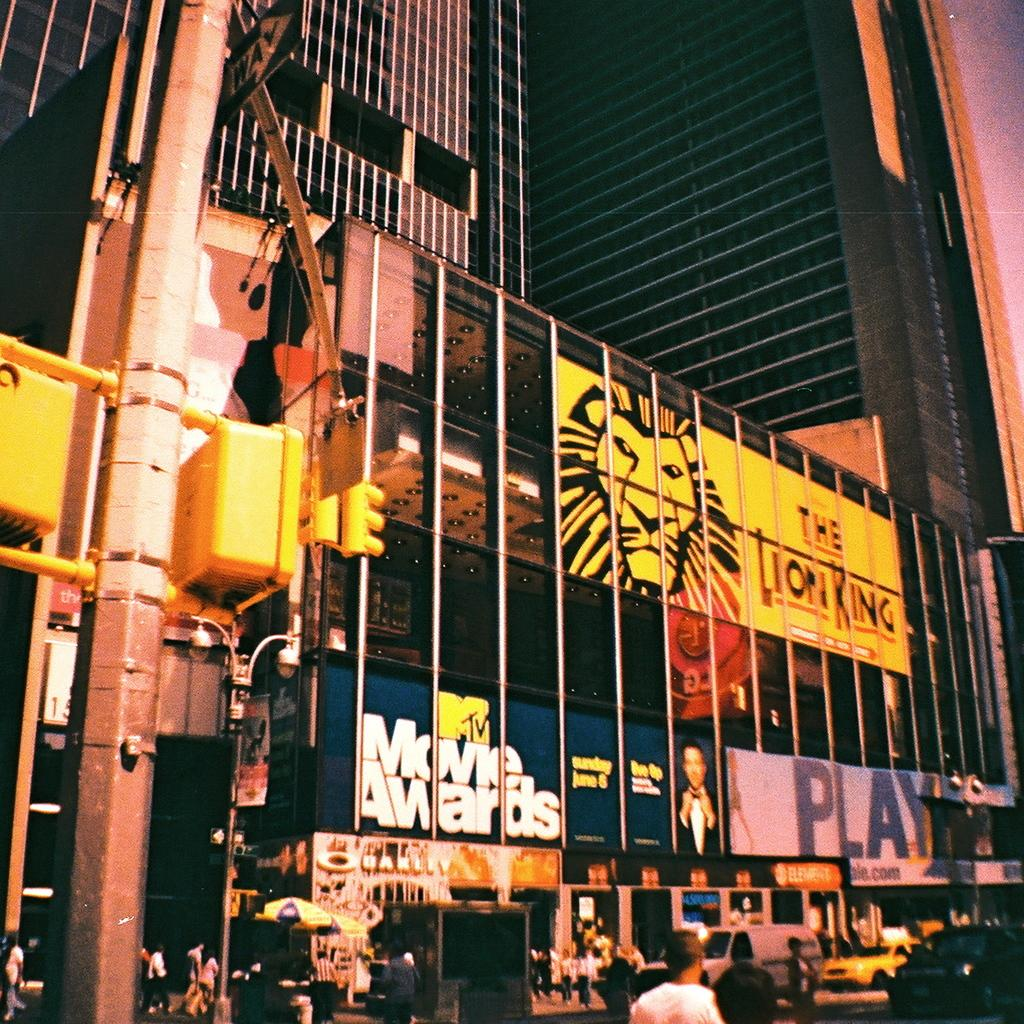<image>
Share a concise interpretation of the image provided. An electronic billboard advertises the Lion King movie  on the side of a city building. 